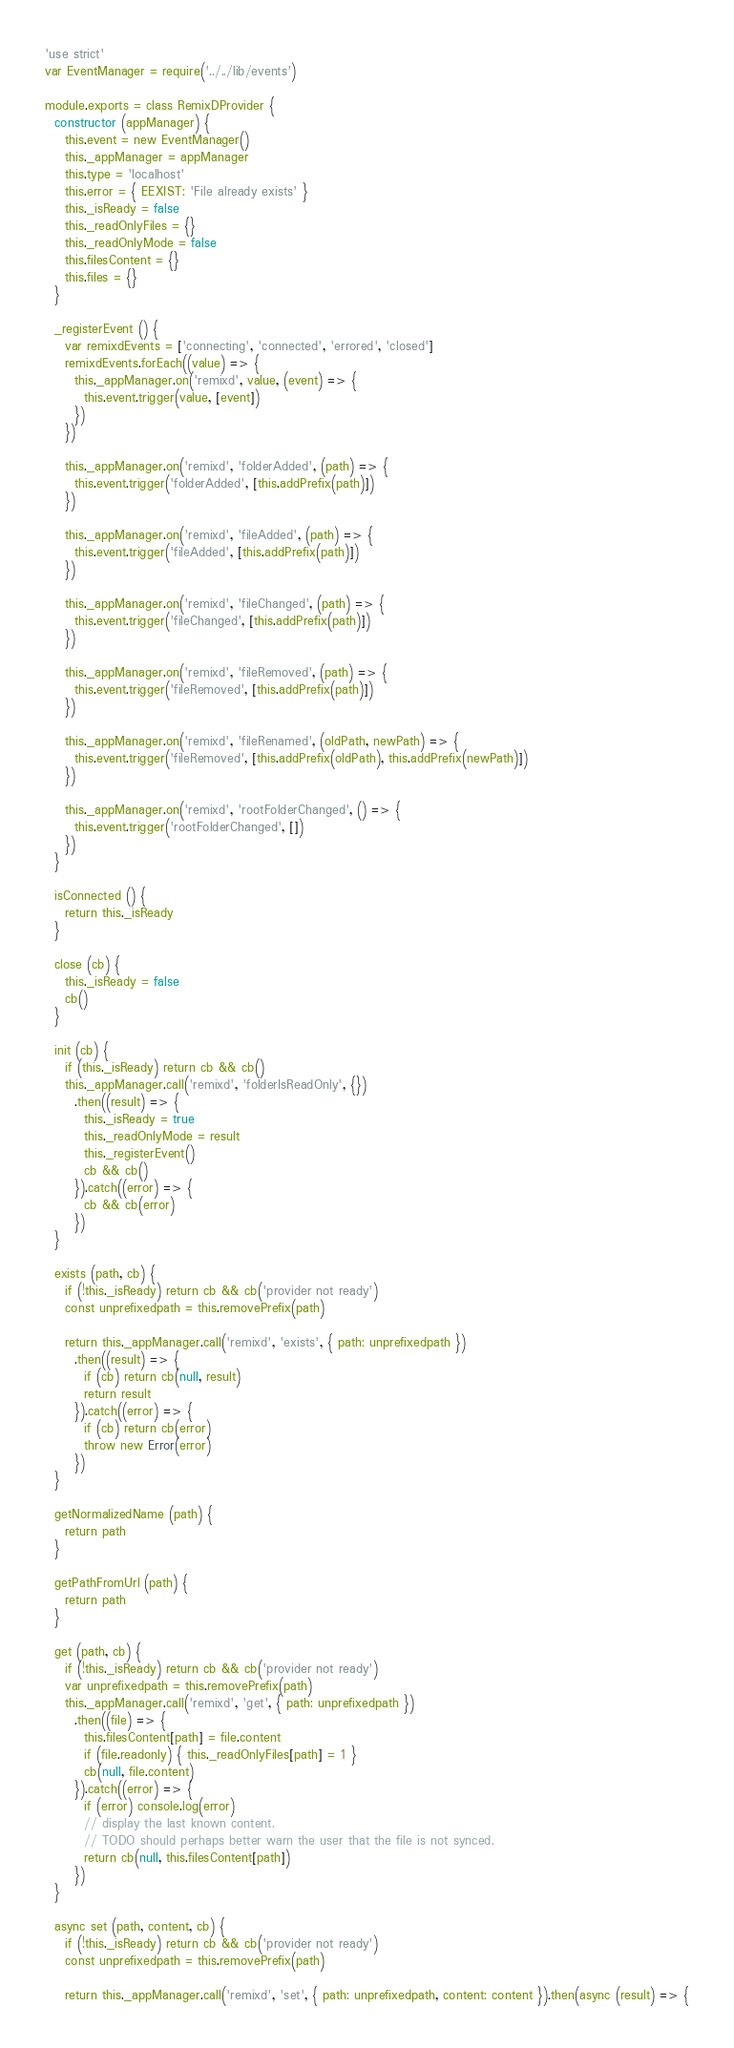<code> <loc_0><loc_0><loc_500><loc_500><_JavaScript_>'use strict'
var EventManager = require('../../lib/events')

module.exports = class RemixDProvider {
  constructor (appManager) {
    this.event = new EventManager()
    this._appManager = appManager
    this.type = 'localhost'
    this.error = { EEXIST: 'File already exists' }
    this._isReady = false
    this._readOnlyFiles = {}
    this._readOnlyMode = false
    this.filesContent = {}
    this.files = {}
  }

  _registerEvent () {
    var remixdEvents = ['connecting', 'connected', 'errored', 'closed']
    remixdEvents.forEach((value) => {
      this._appManager.on('remixd', value, (event) => {
        this.event.trigger(value, [event])
      })
    })

    this._appManager.on('remixd', 'folderAdded', (path) => {
      this.event.trigger('folderAdded', [this.addPrefix(path)])
    })

    this._appManager.on('remixd', 'fileAdded', (path) => {
      this.event.trigger('fileAdded', [this.addPrefix(path)])
    })

    this._appManager.on('remixd', 'fileChanged', (path) => {
      this.event.trigger('fileChanged', [this.addPrefix(path)])
    })

    this._appManager.on('remixd', 'fileRemoved', (path) => {
      this.event.trigger('fileRemoved', [this.addPrefix(path)])
    })

    this._appManager.on('remixd', 'fileRenamed', (oldPath, newPath) => {
      this.event.trigger('fileRemoved', [this.addPrefix(oldPath), this.addPrefix(newPath)])
    })

    this._appManager.on('remixd', 'rootFolderChanged', () => {
      this.event.trigger('rootFolderChanged', [])
    })
  }

  isConnected () {
    return this._isReady
  }

  close (cb) {
    this._isReady = false
    cb()
  }

  init (cb) {
    if (this._isReady) return cb && cb()
    this._appManager.call('remixd', 'folderIsReadOnly', {})
      .then((result) => {
        this._isReady = true
        this._readOnlyMode = result
        this._registerEvent()
        cb && cb()
      }).catch((error) => {
        cb && cb(error)
      })
  }

  exists (path, cb) {
    if (!this._isReady) return cb && cb('provider not ready')
    const unprefixedpath = this.removePrefix(path)

    return this._appManager.call('remixd', 'exists', { path: unprefixedpath })
      .then((result) => {
        if (cb) return cb(null, result)
        return result
      }).catch((error) => {
        if (cb) return cb(error)
        throw new Error(error)
      })
  }

  getNormalizedName (path) {
    return path
  }

  getPathFromUrl (path) {
    return path
  }

  get (path, cb) {
    if (!this._isReady) return cb && cb('provider not ready')
    var unprefixedpath = this.removePrefix(path)
    this._appManager.call('remixd', 'get', { path: unprefixedpath })
      .then((file) => {
        this.filesContent[path] = file.content
        if (file.readonly) { this._readOnlyFiles[path] = 1 }
        cb(null, file.content)
      }).catch((error) => {
        if (error) console.log(error)
        // display the last known content.
        // TODO should perhaps better warn the user that the file is not synced.
        return cb(null, this.filesContent[path])
      })
  }

  async set (path, content, cb) {
    if (!this._isReady) return cb && cb('provider not ready')
    const unprefixedpath = this.removePrefix(path)

    return this._appManager.call('remixd', 'set', { path: unprefixedpath, content: content }).then(async (result) => {</code> 